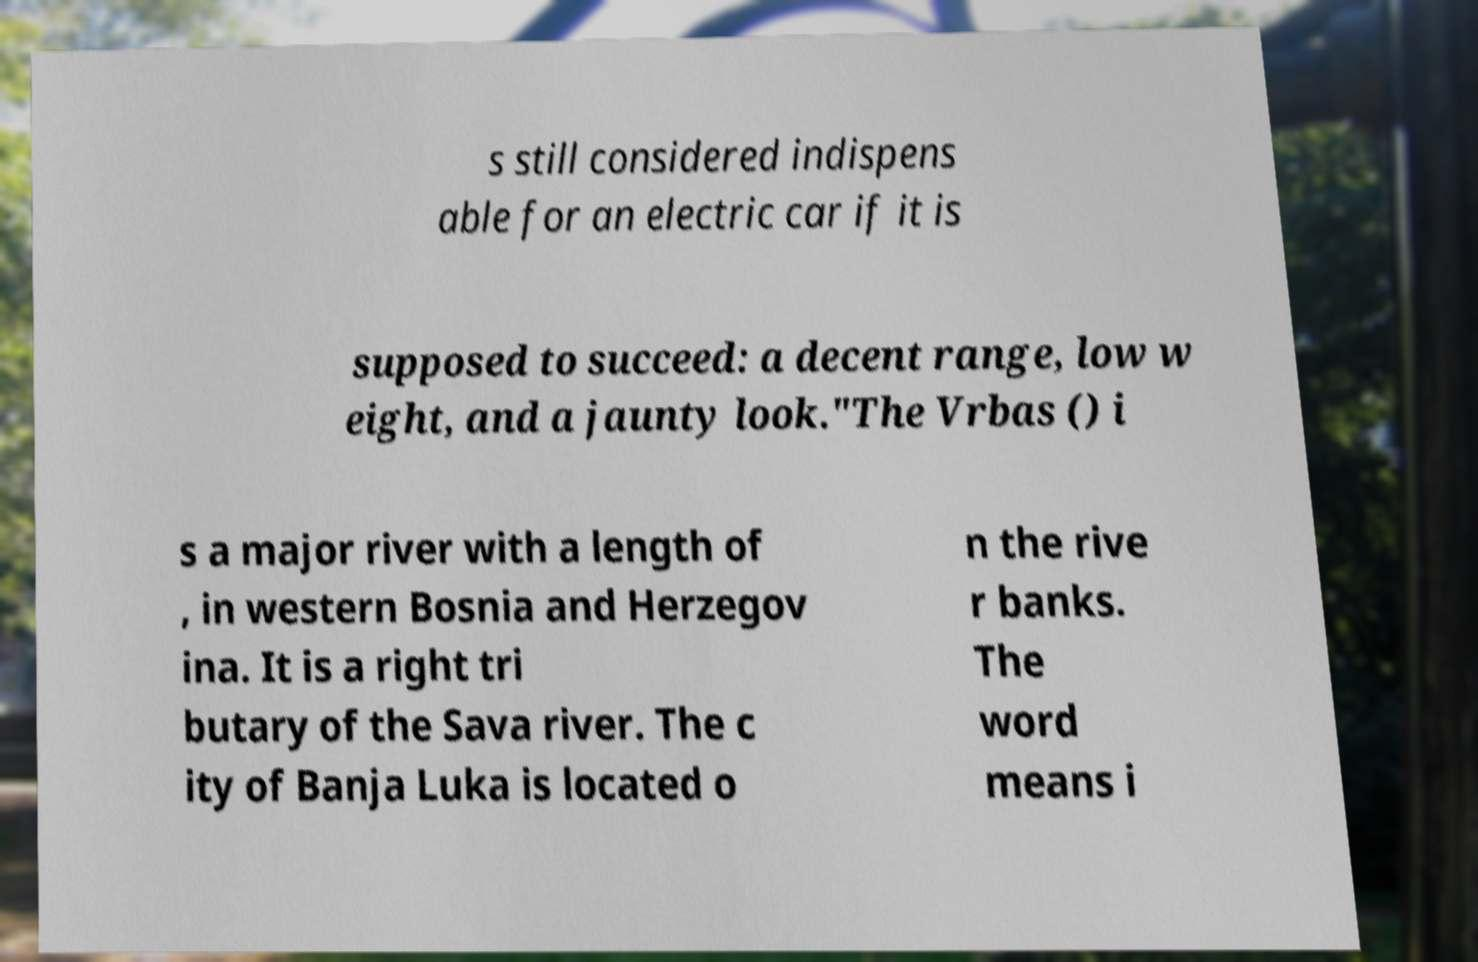Can you accurately transcribe the text from the provided image for me? s still considered indispens able for an electric car if it is supposed to succeed: a decent range, low w eight, and a jaunty look."The Vrbas () i s a major river with a length of , in western Bosnia and Herzegov ina. It is a right tri butary of the Sava river. The c ity of Banja Luka is located o n the rive r banks. The word means i 